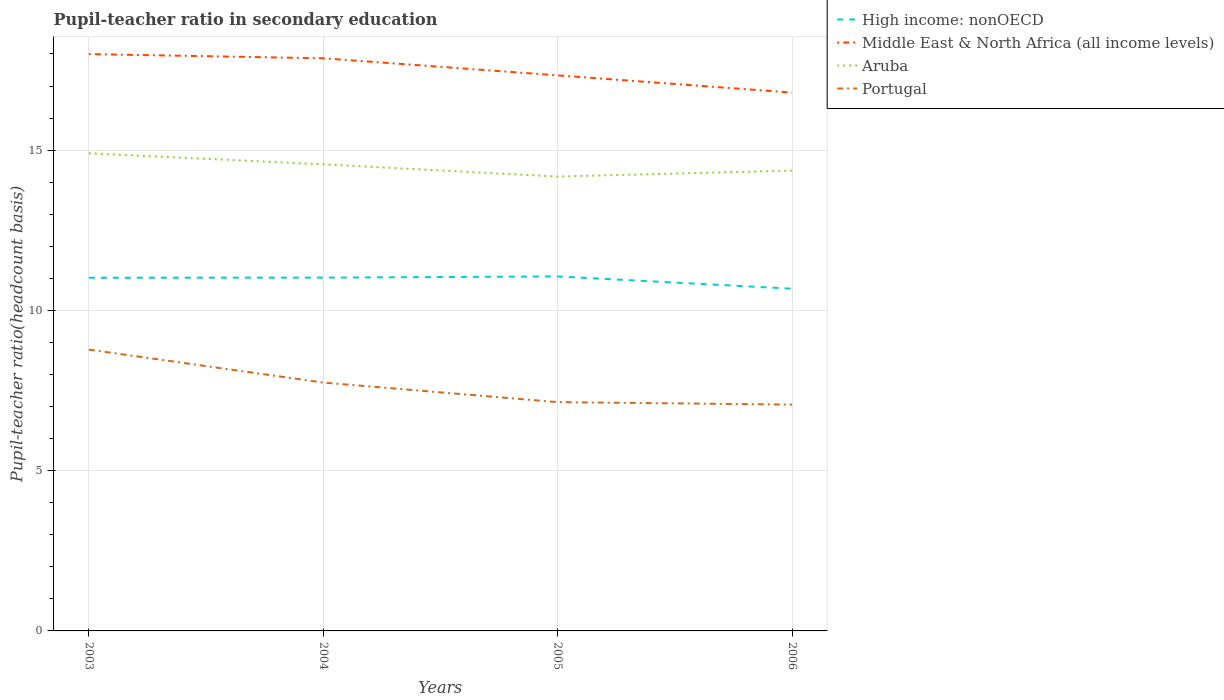How many different coloured lines are there?
Offer a terse response. 4. Does the line corresponding to High income: nonOECD intersect with the line corresponding to Aruba?
Provide a succinct answer. No. Across all years, what is the maximum pupil-teacher ratio in secondary education in Middle East & North Africa (all income levels)?
Your answer should be very brief. 16.8. In which year was the pupil-teacher ratio in secondary education in Aruba maximum?
Keep it short and to the point. 2005. What is the total pupil-teacher ratio in secondary education in Portugal in the graph?
Make the answer very short. 1.03. What is the difference between the highest and the second highest pupil-teacher ratio in secondary education in Middle East & North Africa (all income levels)?
Give a very brief answer. 1.2. What is the difference between the highest and the lowest pupil-teacher ratio in secondary education in Portugal?
Make the answer very short. 2. How many years are there in the graph?
Give a very brief answer. 4. What is the difference between two consecutive major ticks on the Y-axis?
Provide a succinct answer. 5. How many legend labels are there?
Your answer should be very brief. 4. What is the title of the graph?
Ensure brevity in your answer.  Pupil-teacher ratio in secondary education. What is the label or title of the Y-axis?
Offer a very short reply. Pupil-teacher ratio(headcount basis). What is the Pupil-teacher ratio(headcount basis) of High income: nonOECD in 2003?
Your response must be concise. 11.02. What is the Pupil-teacher ratio(headcount basis) of Middle East & North Africa (all income levels) in 2003?
Your answer should be very brief. 18. What is the Pupil-teacher ratio(headcount basis) of Aruba in 2003?
Provide a short and direct response. 14.9. What is the Pupil-teacher ratio(headcount basis) of Portugal in 2003?
Your answer should be compact. 8.78. What is the Pupil-teacher ratio(headcount basis) of High income: nonOECD in 2004?
Provide a succinct answer. 11.02. What is the Pupil-teacher ratio(headcount basis) in Middle East & North Africa (all income levels) in 2004?
Your answer should be very brief. 17.87. What is the Pupil-teacher ratio(headcount basis) in Aruba in 2004?
Provide a succinct answer. 14.56. What is the Pupil-teacher ratio(headcount basis) of Portugal in 2004?
Ensure brevity in your answer.  7.75. What is the Pupil-teacher ratio(headcount basis) in High income: nonOECD in 2005?
Ensure brevity in your answer.  11.06. What is the Pupil-teacher ratio(headcount basis) in Middle East & North Africa (all income levels) in 2005?
Your answer should be very brief. 17.33. What is the Pupil-teacher ratio(headcount basis) in Aruba in 2005?
Keep it short and to the point. 14.18. What is the Pupil-teacher ratio(headcount basis) in Portugal in 2005?
Offer a very short reply. 7.14. What is the Pupil-teacher ratio(headcount basis) of High income: nonOECD in 2006?
Offer a terse response. 10.68. What is the Pupil-teacher ratio(headcount basis) of Middle East & North Africa (all income levels) in 2006?
Provide a short and direct response. 16.8. What is the Pupil-teacher ratio(headcount basis) of Aruba in 2006?
Make the answer very short. 14.36. What is the Pupil-teacher ratio(headcount basis) of Portugal in 2006?
Keep it short and to the point. 7.06. Across all years, what is the maximum Pupil-teacher ratio(headcount basis) in High income: nonOECD?
Offer a terse response. 11.06. Across all years, what is the maximum Pupil-teacher ratio(headcount basis) in Middle East & North Africa (all income levels)?
Offer a terse response. 18. Across all years, what is the maximum Pupil-teacher ratio(headcount basis) in Aruba?
Provide a succinct answer. 14.9. Across all years, what is the maximum Pupil-teacher ratio(headcount basis) in Portugal?
Offer a very short reply. 8.78. Across all years, what is the minimum Pupil-teacher ratio(headcount basis) in High income: nonOECD?
Keep it short and to the point. 10.68. Across all years, what is the minimum Pupil-teacher ratio(headcount basis) of Middle East & North Africa (all income levels)?
Your response must be concise. 16.8. Across all years, what is the minimum Pupil-teacher ratio(headcount basis) in Aruba?
Give a very brief answer. 14.18. Across all years, what is the minimum Pupil-teacher ratio(headcount basis) in Portugal?
Your answer should be compact. 7.06. What is the total Pupil-teacher ratio(headcount basis) of High income: nonOECD in the graph?
Your answer should be compact. 43.78. What is the total Pupil-teacher ratio(headcount basis) of Middle East & North Africa (all income levels) in the graph?
Provide a succinct answer. 69.99. What is the total Pupil-teacher ratio(headcount basis) in Aruba in the graph?
Give a very brief answer. 57.99. What is the total Pupil-teacher ratio(headcount basis) of Portugal in the graph?
Keep it short and to the point. 30.72. What is the difference between the Pupil-teacher ratio(headcount basis) in High income: nonOECD in 2003 and that in 2004?
Keep it short and to the point. -0. What is the difference between the Pupil-teacher ratio(headcount basis) of Middle East & North Africa (all income levels) in 2003 and that in 2004?
Provide a short and direct response. 0.13. What is the difference between the Pupil-teacher ratio(headcount basis) of Aruba in 2003 and that in 2004?
Offer a terse response. 0.34. What is the difference between the Pupil-teacher ratio(headcount basis) of Portugal in 2003 and that in 2004?
Provide a succinct answer. 1.03. What is the difference between the Pupil-teacher ratio(headcount basis) in High income: nonOECD in 2003 and that in 2005?
Keep it short and to the point. -0.04. What is the difference between the Pupil-teacher ratio(headcount basis) in Middle East & North Africa (all income levels) in 2003 and that in 2005?
Make the answer very short. 0.66. What is the difference between the Pupil-teacher ratio(headcount basis) in Aruba in 2003 and that in 2005?
Provide a short and direct response. 0.72. What is the difference between the Pupil-teacher ratio(headcount basis) of Portugal in 2003 and that in 2005?
Your answer should be compact. 1.64. What is the difference between the Pupil-teacher ratio(headcount basis) in High income: nonOECD in 2003 and that in 2006?
Keep it short and to the point. 0.34. What is the difference between the Pupil-teacher ratio(headcount basis) of Middle East & North Africa (all income levels) in 2003 and that in 2006?
Keep it short and to the point. 1.2. What is the difference between the Pupil-teacher ratio(headcount basis) of Aruba in 2003 and that in 2006?
Make the answer very short. 0.54. What is the difference between the Pupil-teacher ratio(headcount basis) in Portugal in 2003 and that in 2006?
Make the answer very short. 1.72. What is the difference between the Pupil-teacher ratio(headcount basis) of High income: nonOECD in 2004 and that in 2005?
Ensure brevity in your answer.  -0.04. What is the difference between the Pupil-teacher ratio(headcount basis) in Middle East & North Africa (all income levels) in 2004 and that in 2005?
Your answer should be compact. 0.53. What is the difference between the Pupil-teacher ratio(headcount basis) in Aruba in 2004 and that in 2005?
Provide a short and direct response. 0.38. What is the difference between the Pupil-teacher ratio(headcount basis) in Portugal in 2004 and that in 2005?
Your answer should be very brief. 0.61. What is the difference between the Pupil-teacher ratio(headcount basis) of High income: nonOECD in 2004 and that in 2006?
Provide a short and direct response. 0.35. What is the difference between the Pupil-teacher ratio(headcount basis) in Middle East & North Africa (all income levels) in 2004 and that in 2006?
Provide a succinct answer. 1.07. What is the difference between the Pupil-teacher ratio(headcount basis) of Aruba in 2004 and that in 2006?
Offer a terse response. 0.2. What is the difference between the Pupil-teacher ratio(headcount basis) of Portugal in 2004 and that in 2006?
Ensure brevity in your answer.  0.69. What is the difference between the Pupil-teacher ratio(headcount basis) of High income: nonOECD in 2005 and that in 2006?
Offer a terse response. 0.38. What is the difference between the Pupil-teacher ratio(headcount basis) of Middle East & North Africa (all income levels) in 2005 and that in 2006?
Give a very brief answer. 0.54. What is the difference between the Pupil-teacher ratio(headcount basis) of Aruba in 2005 and that in 2006?
Give a very brief answer. -0.19. What is the difference between the Pupil-teacher ratio(headcount basis) in Portugal in 2005 and that in 2006?
Make the answer very short. 0.08. What is the difference between the Pupil-teacher ratio(headcount basis) in High income: nonOECD in 2003 and the Pupil-teacher ratio(headcount basis) in Middle East & North Africa (all income levels) in 2004?
Make the answer very short. -6.85. What is the difference between the Pupil-teacher ratio(headcount basis) of High income: nonOECD in 2003 and the Pupil-teacher ratio(headcount basis) of Aruba in 2004?
Offer a terse response. -3.54. What is the difference between the Pupil-teacher ratio(headcount basis) in High income: nonOECD in 2003 and the Pupil-teacher ratio(headcount basis) in Portugal in 2004?
Offer a terse response. 3.27. What is the difference between the Pupil-teacher ratio(headcount basis) in Middle East & North Africa (all income levels) in 2003 and the Pupil-teacher ratio(headcount basis) in Aruba in 2004?
Give a very brief answer. 3.44. What is the difference between the Pupil-teacher ratio(headcount basis) of Middle East & North Africa (all income levels) in 2003 and the Pupil-teacher ratio(headcount basis) of Portugal in 2004?
Offer a very short reply. 10.25. What is the difference between the Pupil-teacher ratio(headcount basis) of Aruba in 2003 and the Pupil-teacher ratio(headcount basis) of Portugal in 2004?
Your response must be concise. 7.15. What is the difference between the Pupil-teacher ratio(headcount basis) in High income: nonOECD in 2003 and the Pupil-teacher ratio(headcount basis) in Middle East & North Africa (all income levels) in 2005?
Provide a short and direct response. -6.31. What is the difference between the Pupil-teacher ratio(headcount basis) of High income: nonOECD in 2003 and the Pupil-teacher ratio(headcount basis) of Aruba in 2005?
Give a very brief answer. -3.16. What is the difference between the Pupil-teacher ratio(headcount basis) in High income: nonOECD in 2003 and the Pupil-teacher ratio(headcount basis) in Portugal in 2005?
Offer a very short reply. 3.88. What is the difference between the Pupil-teacher ratio(headcount basis) in Middle East & North Africa (all income levels) in 2003 and the Pupil-teacher ratio(headcount basis) in Aruba in 2005?
Provide a succinct answer. 3.82. What is the difference between the Pupil-teacher ratio(headcount basis) of Middle East & North Africa (all income levels) in 2003 and the Pupil-teacher ratio(headcount basis) of Portugal in 2005?
Your answer should be very brief. 10.86. What is the difference between the Pupil-teacher ratio(headcount basis) of Aruba in 2003 and the Pupil-teacher ratio(headcount basis) of Portugal in 2005?
Provide a succinct answer. 7.76. What is the difference between the Pupil-teacher ratio(headcount basis) of High income: nonOECD in 2003 and the Pupil-teacher ratio(headcount basis) of Middle East & North Africa (all income levels) in 2006?
Provide a succinct answer. -5.78. What is the difference between the Pupil-teacher ratio(headcount basis) in High income: nonOECD in 2003 and the Pupil-teacher ratio(headcount basis) in Aruba in 2006?
Make the answer very short. -3.34. What is the difference between the Pupil-teacher ratio(headcount basis) of High income: nonOECD in 2003 and the Pupil-teacher ratio(headcount basis) of Portugal in 2006?
Provide a short and direct response. 3.96. What is the difference between the Pupil-teacher ratio(headcount basis) in Middle East & North Africa (all income levels) in 2003 and the Pupil-teacher ratio(headcount basis) in Aruba in 2006?
Your answer should be very brief. 3.63. What is the difference between the Pupil-teacher ratio(headcount basis) of Middle East & North Africa (all income levels) in 2003 and the Pupil-teacher ratio(headcount basis) of Portugal in 2006?
Keep it short and to the point. 10.94. What is the difference between the Pupil-teacher ratio(headcount basis) of Aruba in 2003 and the Pupil-teacher ratio(headcount basis) of Portugal in 2006?
Offer a terse response. 7.84. What is the difference between the Pupil-teacher ratio(headcount basis) of High income: nonOECD in 2004 and the Pupil-teacher ratio(headcount basis) of Middle East & North Africa (all income levels) in 2005?
Offer a very short reply. -6.31. What is the difference between the Pupil-teacher ratio(headcount basis) of High income: nonOECD in 2004 and the Pupil-teacher ratio(headcount basis) of Aruba in 2005?
Give a very brief answer. -3.15. What is the difference between the Pupil-teacher ratio(headcount basis) in High income: nonOECD in 2004 and the Pupil-teacher ratio(headcount basis) in Portugal in 2005?
Your answer should be compact. 3.88. What is the difference between the Pupil-teacher ratio(headcount basis) in Middle East & North Africa (all income levels) in 2004 and the Pupil-teacher ratio(headcount basis) in Aruba in 2005?
Give a very brief answer. 3.69. What is the difference between the Pupil-teacher ratio(headcount basis) of Middle East & North Africa (all income levels) in 2004 and the Pupil-teacher ratio(headcount basis) of Portugal in 2005?
Make the answer very short. 10.73. What is the difference between the Pupil-teacher ratio(headcount basis) of Aruba in 2004 and the Pupil-teacher ratio(headcount basis) of Portugal in 2005?
Provide a succinct answer. 7.42. What is the difference between the Pupil-teacher ratio(headcount basis) in High income: nonOECD in 2004 and the Pupil-teacher ratio(headcount basis) in Middle East & North Africa (all income levels) in 2006?
Give a very brief answer. -5.77. What is the difference between the Pupil-teacher ratio(headcount basis) in High income: nonOECD in 2004 and the Pupil-teacher ratio(headcount basis) in Aruba in 2006?
Make the answer very short. -3.34. What is the difference between the Pupil-teacher ratio(headcount basis) of High income: nonOECD in 2004 and the Pupil-teacher ratio(headcount basis) of Portugal in 2006?
Your answer should be compact. 3.96. What is the difference between the Pupil-teacher ratio(headcount basis) of Middle East & North Africa (all income levels) in 2004 and the Pupil-teacher ratio(headcount basis) of Aruba in 2006?
Provide a succinct answer. 3.5. What is the difference between the Pupil-teacher ratio(headcount basis) of Middle East & North Africa (all income levels) in 2004 and the Pupil-teacher ratio(headcount basis) of Portugal in 2006?
Ensure brevity in your answer.  10.8. What is the difference between the Pupil-teacher ratio(headcount basis) in Aruba in 2004 and the Pupil-teacher ratio(headcount basis) in Portugal in 2006?
Offer a very short reply. 7.5. What is the difference between the Pupil-teacher ratio(headcount basis) in High income: nonOECD in 2005 and the Pupil-teacher ratio(headcount basis) in Middle East & North Africa (all income levels) in 2006?
Make the answer very short. -5.74. What is the difference between the Pupil-teacher ratio(headcount basis) in High income: nonOECD in 2005 and the Pupil-teacher ratio(headcount basis) in Aruba in 2006?
Offer a very short reply. -3.3. What is the difference between the Pupil-teacher ratio(headcount basis) in High income: nonOECD in 2005 and the Pupil-teacher ratio(headcount basis) in Portugal in 2006?
Offer a very short reply. 4. What is the difference between the Pupil-teacher ratio(headcount basis) in Middle East & North Africa (all income levels) in 2005 and the Pupil-teacher ratio(headcount basis) in Aruba in 2006?
Your answer should be very brief. 2.97. What is the difference between the Pupil-teacher ratio(headcount basis) in Middle East & North Africa (all income levels) in 2005 and the Pupil-teacher ratio(headcount basis) in Portugal in 2006?
Provide a succinct answer. 10.27. What is the difference between the Pupil-teacher ratio(headcount basis) of Aruba in 2005 and the Pupil-teacher ratio(headcount basis) of Portugal in 2006?
Make the answer very short. 7.11. What is the average Pupil-teacher ratio(headcount basis) in High income: nonOECD per year?
Your answer should be compact. 10.94. What is the average Pupil-teacher ratio(headcount basis) in Middle East & North Africa (all income levels) per year?
Give a very brief answer. 17.5. What is the average Pupil-teacher ratio(headcount basis) of Aruba per year?
Your answer should be very brief. 14.5. What is the average Pupil-teacher ratio(headcount basis) of Portugal per year?
Provide a succinct answer. 7.68. In the year 2003, what is the difference between the Pupil-teacher ratio(headcount basis) in High income: nonOECD and Pupil-teacher ratio(headcount basis) in Middle East & North Africa (all income levels)?
Give a very brief answer. -6.98. In the year 2003, what is the difference between the Pupil-teacher ratio(headcount basis) in High income: nonOECD and Pupil-teacher ratio(headcount basis) in Aruba?
Your answer should be very brief. -3.88. In the year 2003, what is the difference between the Pupil-teacher ratio(headcount basis) in High income: nonOECD and Pupil-teacher ratio(headcount basis) in Portugal?
Give a very brief answer. 2.24. In the year 2003, what is the difference between the Pupil-teacher ratio(headcount basis) in Middle East & North Africa (all income levels) and Pupil-teacher ratio(headcount basis) in Aruba?
Offer a terse response. 3.1. In the year 2003, what is the difference between the Pupil-teacher ratio(headcount basis) in Middle East & North Africa (all income levels) and Pupil-teacher ratio(headcount basis) in Portugal?
Provide a succinct answer. 9.22. In the year 2003, what is the difference between the Pupil-teacher ratio(headcount basis) in Aruba and Pupil-teacher ratio(headcount basis) in Portugal?
Make the answer very short. 6.12. In the year 2004, what is the difference between the Pupil-teacher ratio(headcount basis) in High income: nonOECD and Pupil-teacher ratio(headcount basis) in Middle East & North Africa (all income levels)?
Offer a very short reply. -6.84. In the year 2004, what is the difference between the Pupil-teacher ratio(headcount basis) in High income: nonOECD and Pupil-teacher ratio(headcount basis) in Aruba?
Give a very brief answer. -3.54. In the year 2004, what is the difference between the Pupil-teacher ratio(headcount basis) in High income: nonOECD and Pupil-teacher ratio(headcount basis) in Portugal?
Your response must be concise. 3.27. In the year 2004, what is the difference between the Pupil-teacher ratio(headcount basis) in Middle East & North Africa (all income levels) and Pupil-teacher ratio(headcount basis) in Aruba?
Offer a terse response. 3.31. In the year 2004, what is the difference between the Pupil-teacher ratio(headcount basis) of Middle East & North Africa (all income levels) and Pupil-teacher ratio(headcount basis) of Portugal?
Offer a very short reply. 10.12. In the year 2004, what is the difference between the Pupil-teacher ratio(headcount basis) of Aruba and Pupil-teacher ratio(headcount basis) of Portugal?
Ensure brevity in your answer.  6.81. In the year 2005, what is the difference between the Pupil-teacher ratio(headcount basis) in High income: nonOECD and Pupil-teacher ratio(headcount basis) in Middle East & North Africa (all income levels)?
Give a very brief answer. -6.27. In the year 2005, what is the difference between the Pupil-teacher ratio(headcount basis) in High income: nonOECD and Pupil-teacher ratio(headcount basis) in Aruba?
Provide a short and direct response. -3.12. In the year 2005, what is the difference between the Pupil-teacher ratio(headcount basis) of High income: nonOECD and Pupil-teacher ratio(headcount basis) of Portugal?
Offer a terse response. 3.92. In the year 2005, what is the difference between the Pupil-teacher ratio(headcount basis) of Middle East & North Africa (all income levels) and Pupil-teacher ratio(headcount basis) of Aruba?
Your answer should be very brief. 3.16. In the year 2005, what is the difference between the Pupil-teacher ratio(headcount basis) in Middle East & North Africa (all income levels) and Pupil-teacher ratio(headcount basis) in Portugal?
Provide a short and direct response. 10.19. In the year 2005, what is the difference between the Pupil-teacher ratio(headcount basis) in Aruba and Pupil-teacher ratio(headcount basis) in Portugal?
Offer a terse response. 7.04. In the year 2006, what is the difference between the Pupil-teacher ratio(headcount basis) of High income: nonOECD and Pupil-teacher ratio(headcount basis) of Middle East & North Africa (all income levels)?
Offer a terse response. -6.12. In the year 2006, what is the difference between the Pupil-teacher ratio(headcount basis) in High income: nonOECD and Pupil-teacher ratio(headcount basis) in Aruba?
Offer a terse response. -3.68. In the year 2006, what is the difference between the Pupil-teacher ratio(headcount basis) of High income: nonOECD and Pupil-teacher ratio(headcount basis) of Portugal?
Offer a terse response. 3.62. In the year 2006, what is the difference between the Pupil-teacher ratio(headcount basis) of Middle East & North Africa (all income levels) and Pupil-teacher ratio(headcount basis) of Aruba?
Make the answer very short. 2.43. In the year 2006, what is the difference between the Pupil-teacher ratio(headcount basis) of Middle East & North Africa (all income levels) and Pupil-teacher ratio(headcount basis) of Portugal?
Keep it short and to the point. 9.73. In the year 2006, what is the difference between the Pupil-teacher ratio(headcount basis) of Aruba and Pupil-teacher ratio(headcount basis) of Portugal?
Keep it short and to the point. 7.3. What is the ratio of the Pupil-teacher ratio(headcount basis) of High income: nonOECD in 2003 to that in 2004?
Your answer should be compact. 1. What is the ratio of the Pupil-teacher ratio(headcount basis) of Middle East & North Africa (all income levels) in 2003 to that in 2004?
Your answer should be compact. 1.01. What is the ratio of the Pupil-teacher ratio(headcount basis) in Aruba in 2003 to that in 2004?
Offer a terse response. 1.02. What is the ratio of the Pupil-teacher ratio(headcount basis) in Portugal in 2003 to that in 2004?
Provide a succinct answer. 1.13. What is the ratio of the Pupil-teacher ratio(headcount basis) of High income: nonOECD in 2003 to that in 2005?
Provide a succinct answer. 1. What is the ratio of the Pupil-teacher ratio(headcount basis) of Middle East & North Africa (all income levels) in 2003 to that in 2005?
Ensure brevity in your answer.  1.04. What is the ratio of the Pupil-teacher ratio(headcount basis) of Aruba in 2003 to that in 2005?
Offer a terse response. 1.05. What is the ratio of the Pupil-teacher ratio(headcount basis) in Portugal in 2003 to that in 2005?
Keep it short and to the point. 1.23. What is the ratio of the Pupil-teacher ratio(headcount basis) in High income: nonOECD in 2003 to that in 2006?
Your answer should be compact. 1.03. What is the ratio of the Pupil-teacher ratio(headcount basis) of Middle East & North Africa (all income levels) in 2003 to that in 2006?
Make the answer very short. 1.07. What is the ratio of the Pupil-teacher ratio(headcount basis) of Aruba in 2003 to that in 2006?
Offer a terse response. 1.04. What is the ratio of the Pupil-teacher ratio(headcount basis) in Portugal in 2003 to that in 2006?
Your response must be concise. 1.24. What is the ratio of the Pupil-teacher ratio(headcount basis) in Middle East & North Africa (all income levels) in 2004 to that in 2005?
Make the answer very short. 1.03. What is the ratio of the Pupil-teacher ratio(headcount basis) in Aruba in 2004 to that in 2005?
Your answer should be compact. 1.03. What is the ratio of the Pupil-teacher ratio(headcount basis) in Portugal in 2004 to that in 2005?
Provide a short and direct response. 1.09. What is the ratio of the Pupil-teacher ratio(headcount basis) in High income: nonOECD in 2004 to that in 2006?
Your answer should be compact. 1.03. What is the ratio of the Pupil-teacher ratio(headcount basis) in Middle East & North Africa (all income levels) in 2004 to that in 2006?
Your response must be concise. 1.06. What is the ratio of the Pupil-teacher ratio(headcount basis) in Aruba in 2004 to that in 2006?
Provide a short and direct response. 1.01. What is the ratio of the Pupil-teacher ratio(headcount basis) of Portugal in 2004 to that in 2006?
Provide a succinct answer. 1.1. What is the ratio of the Pupil-teacher ratio(headcount basis) of High income: nonOECD in 2005 to that in 2006?
Offer a very short reply. 1.04. What is the ratio of the Pupil-teacher ratio(headcount basis) in Middle East & North Africa (all income levels) in 2005 to that in 2006?
Provide a succinct answer. 1.03. What is the ratio of the Pupil-teacher ratio(headcount basis) in Aruba in 2005 to that in 2006?
Offer a very short reply. 0.99. What is the ratio of the Pupil-teacher ratio(headcount basis) of Portugal in 2005 to that in 2006?
Provide a short and direct response. 1.01. What is the difference between the highest and the second highest Pupil-teacher ratio(headcount basis) in High income: nonOECD?
Keep it short and to the point. 0.04. What is the difference between the highest and the second highest Pupil-teacher ratio(headcount basis) of Middle East & North Africa (all income levels)?
Keep it short and to the point. 0.13. What is the difference between the highest and the second highest Pupil-teacher ratio(headcount basis) in Aruba?
Provide a short and direct response. 0.34. What is the difference between the highest and the second highest Pupil-teacher ratio(headcount basis) in Portugal?
Your answer should be very brief. 1.03. What is the difference between the highest and the lowest Pupil-teacher ratio(headcount basis) in High income: nonOECD?
Offer a terse response. 0.38. What is the difference between the highest and the lowest Pupil-teacher ratio(headcount basis) of Middle East & North Africa (all income levels)?
Keep it short and to the point. 1.2. What is the difference between the highest and the lowest Pupil-teacher ratio(headcount basis) in Aruba?
Provide a short and direct response. 0.72. What is the difference between the highest and the lowest Pupil-teacher ratio(headcount basis) in Portugal?
Give a very brief answer. 1.72. 